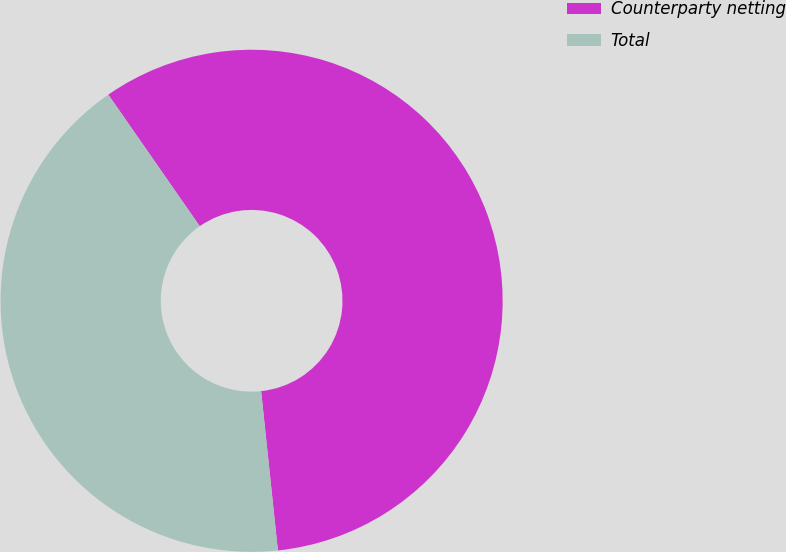Convert chart. <chart><loc_0><loc_0><loc_500><loc_500><pie_chart><fcel>Counterparty netting<fcel>Total<nl><fcel>58.0%<fcel>42.0%<nl></chart> 